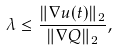Convert formula to latex. <formula><loc_0><loc_0><loc_500><loc_500>\lambda \leq \frac { \| \nabla u ( t ) \| _ { 2 } } { \| \nabla Q \| _ { 2 } } ,</formula> 